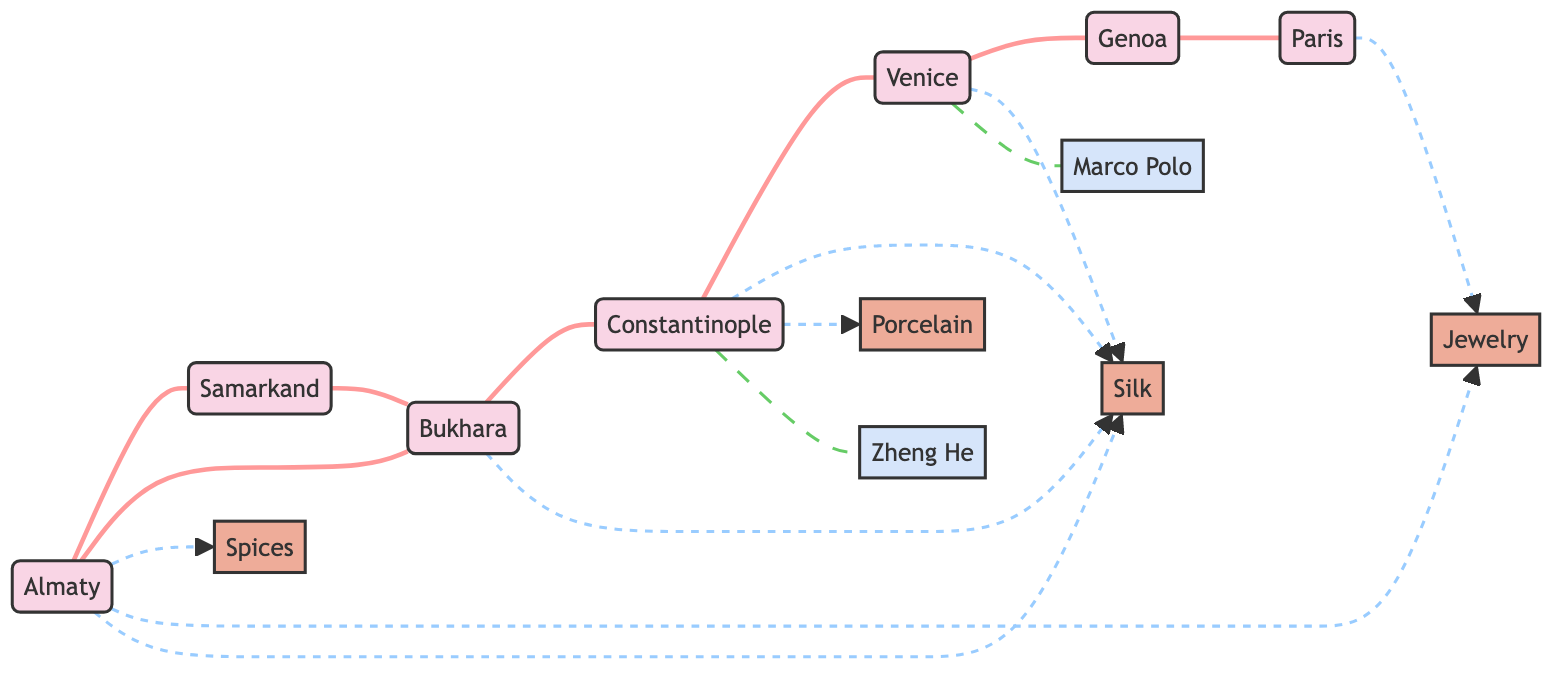What is the total number of nodes in the diagram? To find the total number of nodes, I count each unique location and commodity depicted in the diagram. The nodes are Almaty, Samarkand, Bukhara, Constantinople, Venice, Genoa, Paris, Spices, Silk, Jewelry, Porcelain, Marco Polo, and Zheng He, totaling 12 nodes.
Answer: 12 Which city is directly connected to both Almaty and Bukhara? I look for nodes that have edges connecting to Almaty and Bukhara. Samarkand is connected to Almaty and also connected to Bukhara, making it the only city directly connected to both.
Answer: Samarkand What type of relationship exists between Constantinople and Venice? I examine the edge linking Constantinople to Venice to determine the type of relationship depicted. The edge shows a "Trade Route" label, indicating that there is a trading connection between these two cities.
Answer: Trade Route Which city has the most traded items listed in the diagram? I review the edges linked to each city that indicate traded items. Almaty has three edges (Spices, Jewelry, Silk), while others like Constantinople and Venice have fewer. Since Almaty has the highest number of connections to traded items, it is identified as the city with the most traded items.
Answer: Almaty How many trade routes lead out from Bukhara? I count the edges that start from Bukhara and connect it to other nodes. Bukhara has two trade route edges, one to Samarkand and the other to Constantinople, confirming the total number of trade routes from Bukhara.
Answer: 2 Which two historical figures are associated with Constantinople? I look at the edges coming from Constantinople to see if any historical figures are associated. There are two edges leading to Zheng He and Marco Polo, indicating that both figures are related to Constantinople.
Answer: Zheng He, Marco Polo What type of commodity is linked to both Almaty and Paris? I examine the connected edges for both cities. Almaty is linked to Spices, Jewelry, and Silk, while Paris is linked to Jewelry only. Therefore, the common commodity that connects both cities is Jewelry.
Answer: Jewelry What is the primary commodity traded between Constantinople and Venice? I check the edges stemming from Constantinople to Venice to identify traded items. The only traded commodity identified on the edge connecting these two cities is Silk, therefore, it is concluded as the primary commodity.
Answer: Silk 